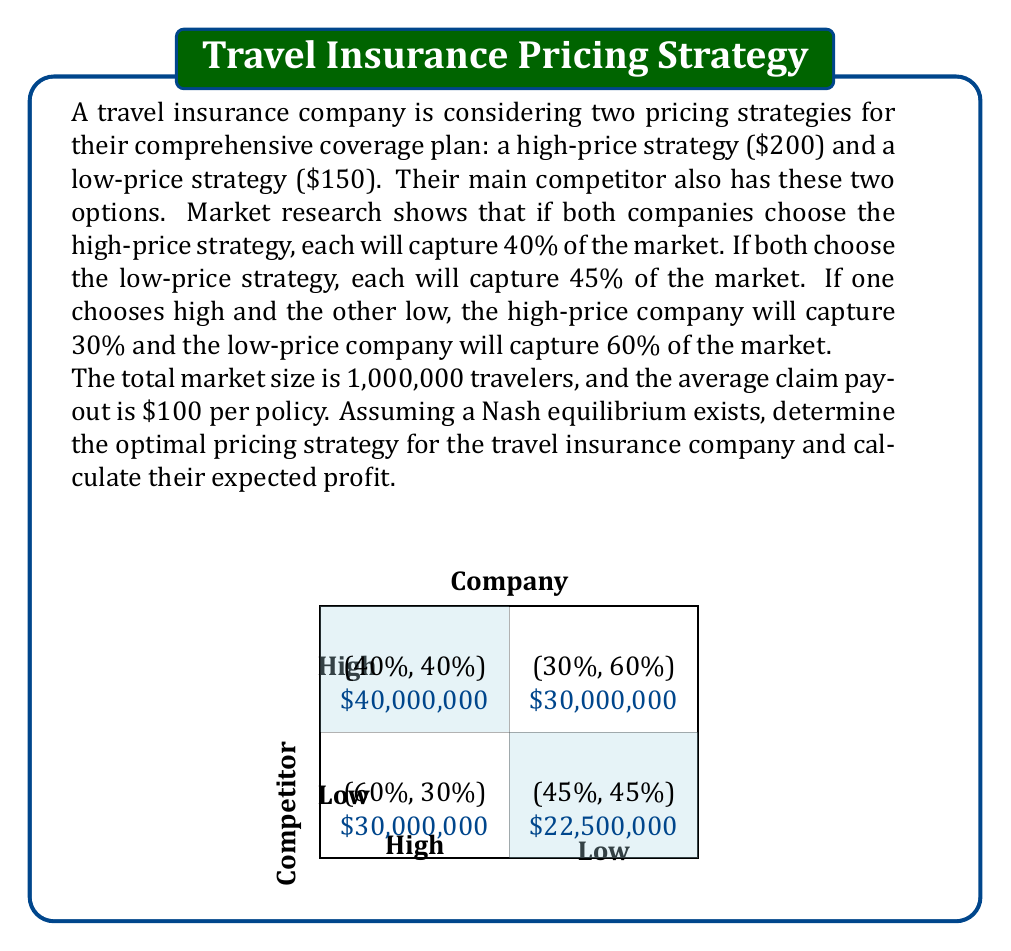Help me with this question. Let's approach this problem step-by-step using game theory:

1) First, we need to calculate the payoffs for each scenario:

   High-High: Profit = Revenue - Costs
   Revenue = 1,000,000 * 0.40 * $200 = $80,000,000
   Costs = 1,000,000 * 0.40 * $100 = $40,000,000
   Profit = $80,000,000 - $40,000,000 = $40,000,000

   Low-Low: Profit = Revenue - Costs
   Revenue = 1,000,000 * 0.45 * $150 = $67,500,000
   Costs = 1,000,000 * 0.45 * $100 = $45,000,000
   Profit = $67,500,000 - $45,000,000 = $22,500,000

   High-Low: Profit = Revenue - Costs
   Revenue = 1,000,000 * 0.30 * $200 = $60,000,000
   Costs = 1,000,000 * 0.30 * $100 = $30,000,000
   Profit = $60,000,000 - $30,000,000 = $30,000,000

   Low-High: Profit = Revenue - Costs
   Revenue = 1,000,000 * 0.60 * $150 = $90,000,000
   Costs = 1,000,000 * 0.60 * $100 = $60,000,000
   Profit = $90,000,000 - $60,000,000 = $30,000,000

2) Now we can set up the payoff matrix:

   $$\begin{matrix}
   & \text{Competitor High} & \text{Competitor Low} \\
   \text{Company High} & (40,000,000, 40,000,000) & (30,000,000, 30,000,000) \\
   \text{Company Low} & (30,000,000, 30,000,000) & (22,500,000, 22,500,000)
   \end{matrix}$$

3) To find the Nash equilibrium, we need to check if any player has an incentive to unilaterally deviate from a given strategy profile:

   - If both choose High: Neither has an incentive to switch to Low (40,000,000 > 30,000,000)
   - If both choose Low: Both have an incentive to switch to High (30,000,000 > 22,500,000)
   - If one chooses High and the other Low: The one choosing Low has an incentive to switch to High

4) Therefore, the Nash equilibrium is for both companies to choose the High-price strategy.

5) At this equilibrium, the company's expected profit is $40,000,000.
Answer: High-price strategy; $40,000,000 profit 